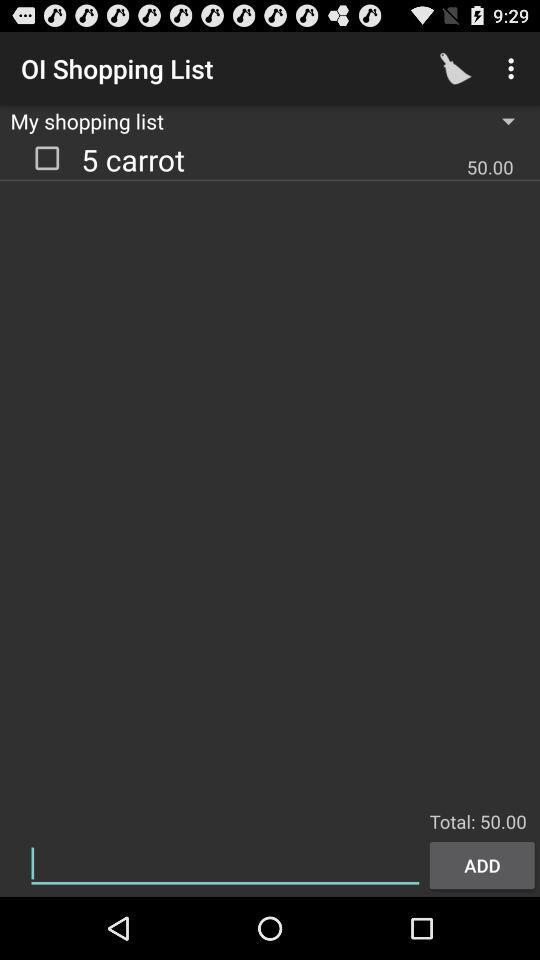What is the number of carrots? The number of carrots is 5. 